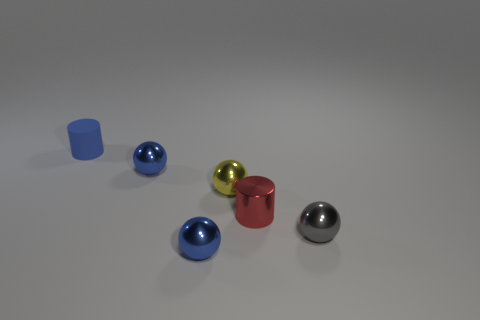Subtract all gray balls. How many balls are left? 3 Subtract all cyan blocks. How many blue spheres are left? 2 Add 2 tiny gray objects. How many objects exist? 8 Subtract 1 spheres. How many spheres are left? 3 Subtract all gray balls. How many balls are left? 3 Subtract all balls. How many objects are left? 2 Subtract 0 green cylinders. How many objects are left? 6 Subtract all blue cylinders. Subtract all green spheres. How many cylinders are left? 1 Subtract all objects. Subtract all big blue matte things. How many objects are left? 0 Add 5 small yellow shiny objects. How many small yellow shiny objects are left? 6 